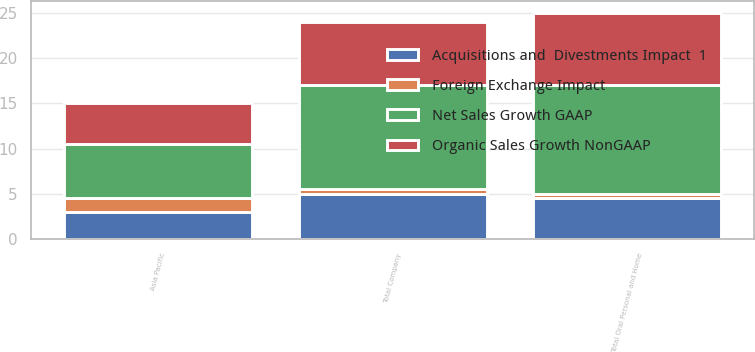Convert chart to OTSL. <chart><loc_0><loc_0><loc_500><loc_500><stacked_bar_chart><ecel><fcel>Asia Pacific<fcel>Total Oral Personal and Home<fcel>Total Company<nl><fcel>Organic Sales Growth NonGAAP<fcel>4.5<fcel>8<fcel>7<nl><fcel>Net Sales Growth GAAP<fcel>6<fcel>12<fcel>11.5<nl><fcel>Foreign Exchange Impact<fcel>1.5<fcel>0.5<fcel>0.5<nl><fcel>Acquisitions and  Divestments Impact  1<fcel>3<fcel>4.5<fcel>5<nl></chart> 